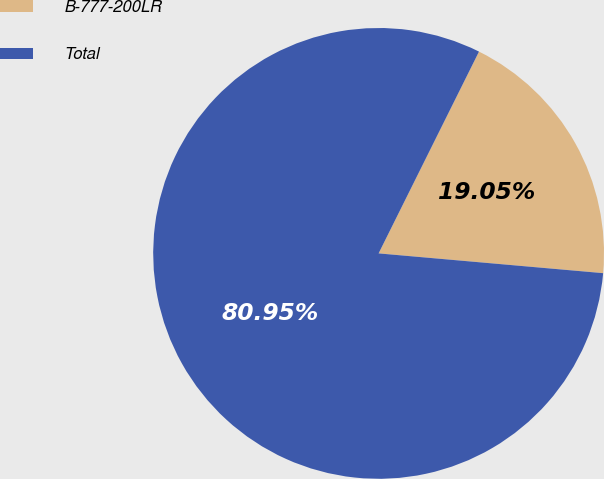<chart> <loc_0><loc_0><loc_500><loc_500><pie_chart><fcel>B-777-200LR<fcel>Total<nl><fcel>19.05%<fcel>80.95%<nl></chart> 